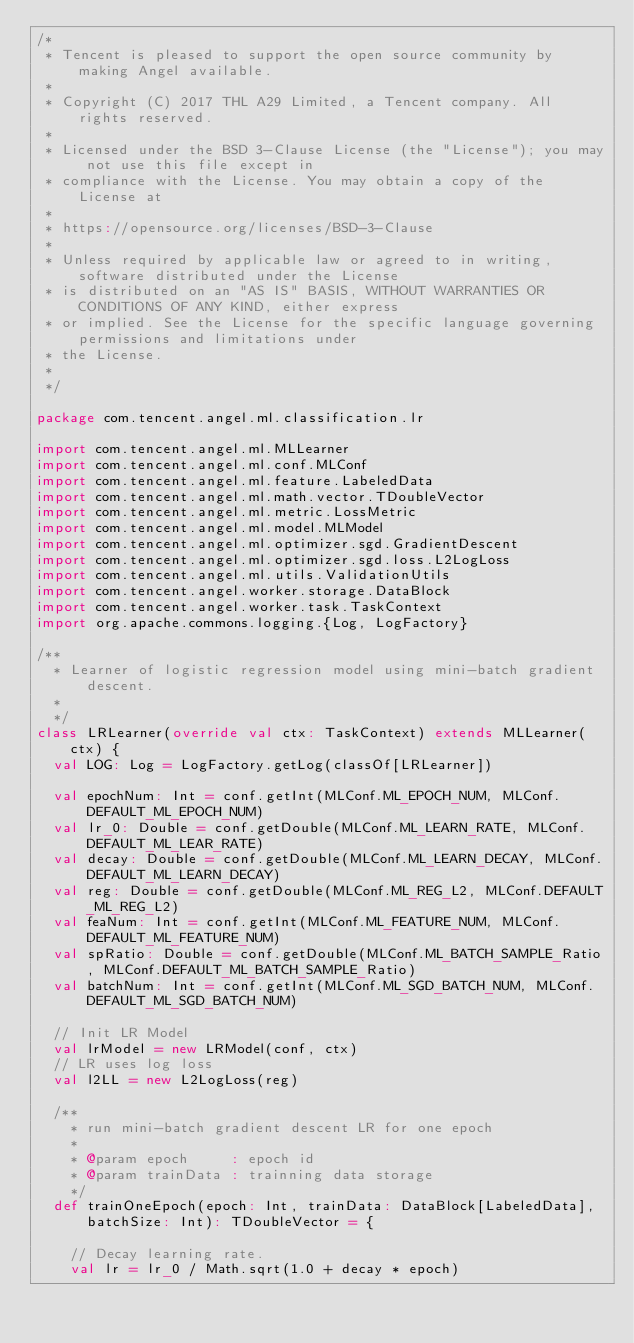Convert code to text. <code><loc_0><loc_0><loc_500><loc_500><_Scala_>/*
 * Tencent is pleased to support the open source community by making Angel available.
 *
 * Copyright (C) 2017 THL A29 Limited, a Tencent company. All rights reserved.
 *
 * Licensed under the BSD 3-Clause License (the "License"); you may not use this file except in
 * compliance with the License. You may obtain a copy of the License at
 *
 * https://opensource.org/licenses/BSD-3-Clause
 *
 * Unless required by applicable law or agreed to in writing, software distributed under the License
 * is distributed on an "AS IS" BASIS, WITHOUT WARRANTIES OR CONDITIONS OF ANY KIND, either express
 * or implied. See the License for the specific language governing permissions and limitations under
 * the License.
 *
 */

package com.tencent.angel.ml.classification.lr

import com.tencent.angel.ml.MLLearner
import com.tencent.angel.ml.conf.MLConf
import com.tencent.angel.ml.feature.LabeledData
import com.tencent.angel.ml.math.vector.TDoubleVector
import com.tencent.angel.ml.metric.LossMetric
import com.tencent.angel.ml.model.MLModel
import com.tencent.angel.ml.optimizer.sgd.GradientDescent
import com.tencent.angel.ml.optimizer.sgd.loss.L2LogLoss
import com.tencent.angel.ml.utils.ValidationUtils
import com.tencent.angel.worker.storage.DataBlock
import com.tencent.angel.worker.task.TaskContext
import org.apache.commons.logging.{Log, LogFactory}

/**
  * Learner of logistic regression model using mini-batch gradient descent.
  *
  */
class LRLearner(override val ctx: TaskContext) extends MLLearner(ctx) {
  val LOG: Log = LogFactory.getLog(classOf[LRLearner])

  val epochNum: Int = conf.getInt(MLConf.ML_EPOCH_NUM, MLConf.DEFAULT_ML_EPOCH_NUM)
  val lr_0: Double = conf.getDouble(MLConf.ML_LEARN_RATE, MLConf.DEFAULT_ML_LEAR_RATE)
  val decay: Double = conf.getDouble(MLConf.ML_LEARN_DECAY, MLConf.DEFAULT_ML_LEARN_DECAY)
  val reg: Double = conf.getDouble(MLConf.ML_REG_L2, MLConf.DEFAULT_ML_REG_L2)
  val feaNum: Int = conf.getInt(MLConf.ML_FEATURE_NUM, MLConf.DEFAULT_ML_FEATURE_NUM)
  val spRatio: Double = conf.getDouble(MLConf.ML_BATCH_SAMPLE_Ratio, MLConf.DEFAULT_ML_BATCH_SAMPLE_Ratio)
  val batchNum: Int = conf.getInt(MLConf.ML_SGD_BATCH_NUM, MLConf.DEFAULT_ML_SGD_BATCH_NUM)

  // Init LR Model
  val lrModel = new LRModel(conf, ctx)
  // LR uses log loss
  val l2LL = new L2LogLoss(reg)

  /**
    * run mini-batch gradient descent LR for one epoch
    *
    * @param epoch     : epoch id
    * @param trainData : trainning data storage
    */
  def trainOneEpoch(epoch: Int, trainData: DataBlock[LabeledData], batchSize: Int): TDoubleVector = {

    // Decay learning rate.
    val lr = lr_0 / Math.sqrt(1.0 + decay * epoch)
</code> 